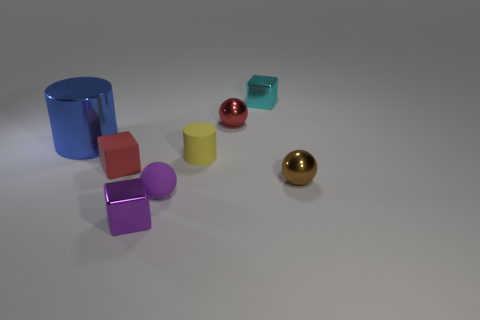Subtract 1 cubes. How many cubes are left? 2 Add 1 brown metallic spheres. How many objects exist? 9 Subtract all tiny red cubes. How many cubes are left? 2 Subtract all cylinders. How many objects are left? 6 Subtract all matte blocks. Subtract all big shiny things. How many objects are left? 6 Add 1 small cylinders. How many small cylinders are left? 2 Add 7 cyan things. How many cyan things exist? 8 Subtract 1 cyan blocks. How many objects are left? 7 Subtract all yellow cylinders. Subtract all purple blocks. How many cylinders are left? 1 